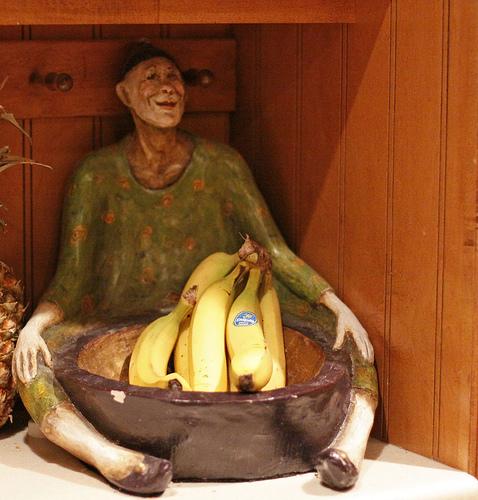What is attached to the bowl?
Keep it brief. Man. Is it sunny?
Short answer required. Yes. Is the bowl of fruit in a niche?
Be succinct. Yes. 